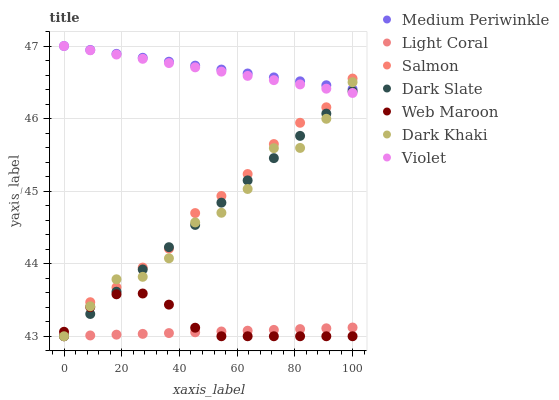Does Light Coral have the minimum area under the curve?
Answer yes or no. Yes. Does Medium Periwinkle have the maximum area under the curve?
Answer yes or no. Yes. Does Salmon have the minimum area under the curve?
Answer yes or no. No. Does Salmon have the maximum area under the curve?
Answer yes or no. No. Is Violet the smoothest?
Answer yes or no. Yes. Is Dark Khaki the roughest?
Answer yes or no. Yes. Is Medium Periwinkle the smoothest?
Answer yes or no. No. Is Medium Periwinkle the roughest?
Answer yes or no. No. Does Dark Khaki have the lowest value?
Answer yes or no. Yes. Does Medium Periwinkle have the lowest value?
Answer yes or no. No. Does Violet have the highest value?
Answer yes or no. Yes. Does Salmon have the highest value?
Answer yes or no. No. Is Light Coral less than Violet?
Answer yes or no. Yes. Is Violet greater than Light Coral?
Answer yes or no. Yes. Does Light Coral intersect Dark Slate?
Answer yes or no. Yes. Is Light Coral less than Dark Slate?
Answer yes or no. No. Is Light Coral greater than Dark Slate?
Answer yes or no. No. Does Light Coral intersect Violet?
Answer yes or no. No. 